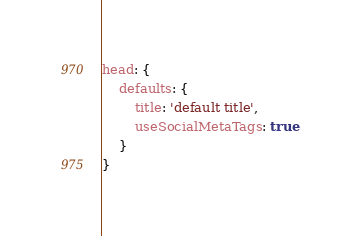<code> <loc_0><loc_0><loc_500><loc_500><_JavaScript_>head: {
    defaults: {
        title: 'default title',
        useSocialMetaTags: true
    }
}
</code> 